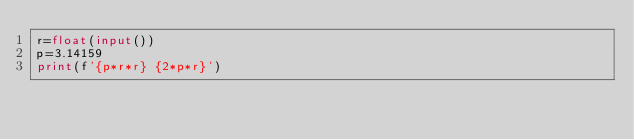Convert code to text. <code><loc_0><loc_0><loc_500><loc_500><_Python_>r=float(input())
p=3.14159
print(f'{p*r*r} {2*p*r}')</code> 